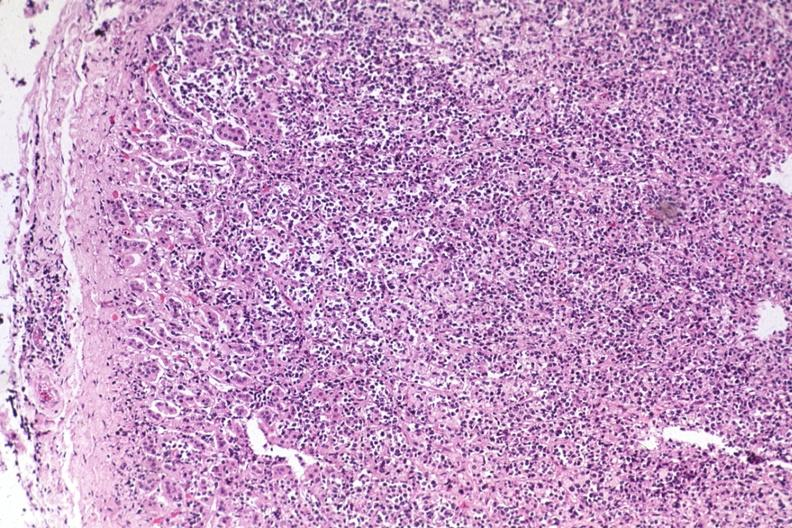s malignant lymphoma present?
Answer the question using a single word or phrase. Yes 